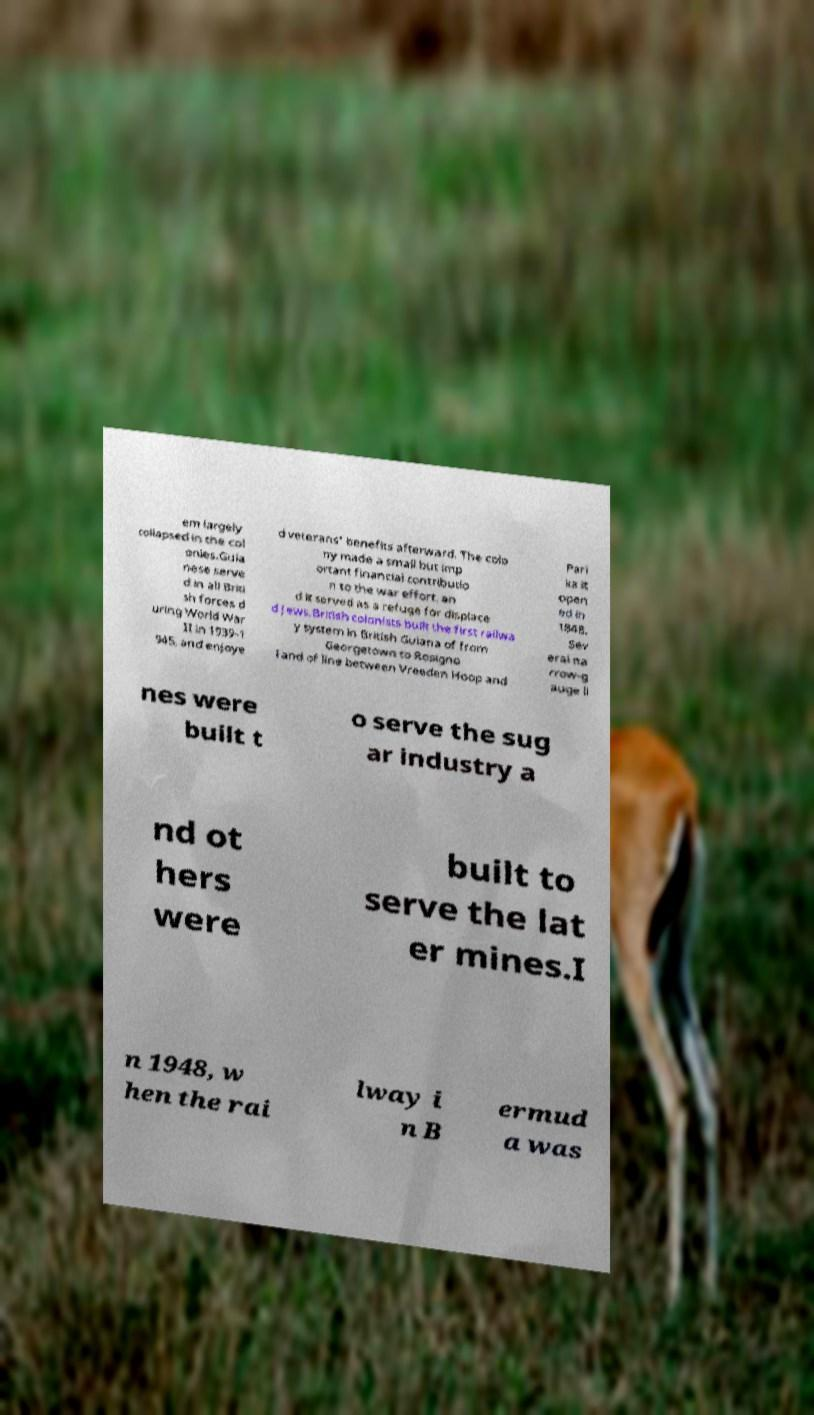What messages or text are displayed in this image? I need them in a readable, typed format. em largely collapsed in the col onies.Guia nese serve d in all Briti sh forces d uring World War II in 1939-1 945, and enjoye d veterans' benefits afterward. The colo ny made a small but imp ortant financial contributio n to the war effort, an d it served as a refuge for displace d Jews.British colonists built the first railwa y system in British Guiana of from Georgetown to Rosigno l and of line between Vreeden Hoop and Pari ka it open ed in 1848. Sev eral na rrow-g auge li nes were built t o serve the sug ar industry a nd ot hers were built to serve the lat er mines.I n 1948, w hen the rai lway i n B ermud a was 